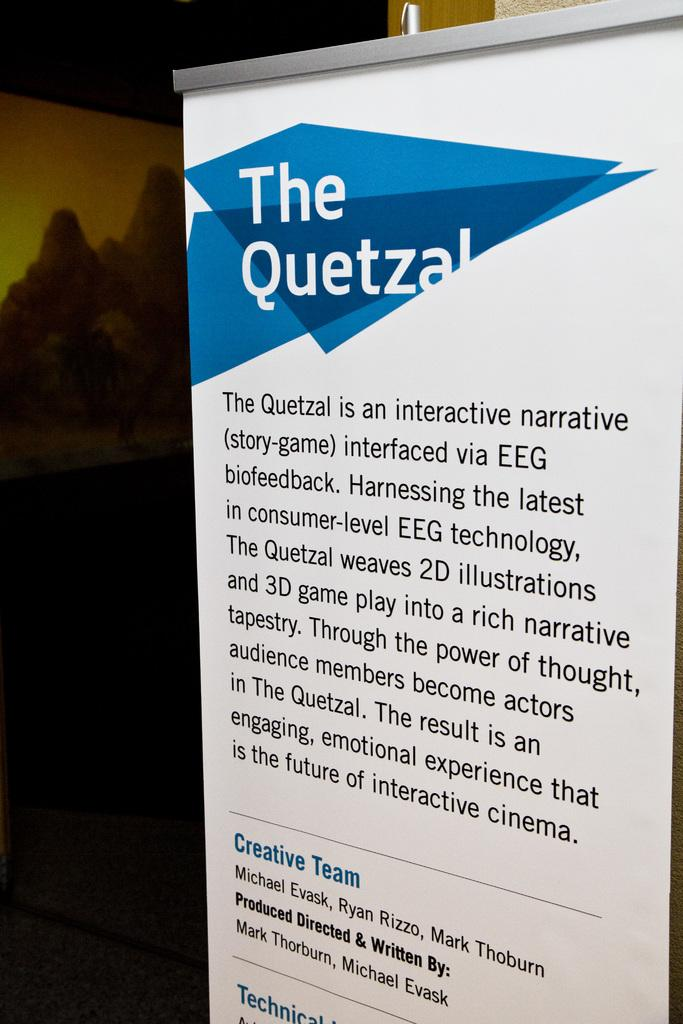<image>
Summarize the visual content of the image. a white page with the title The Quetzal on a blue triangle shape 